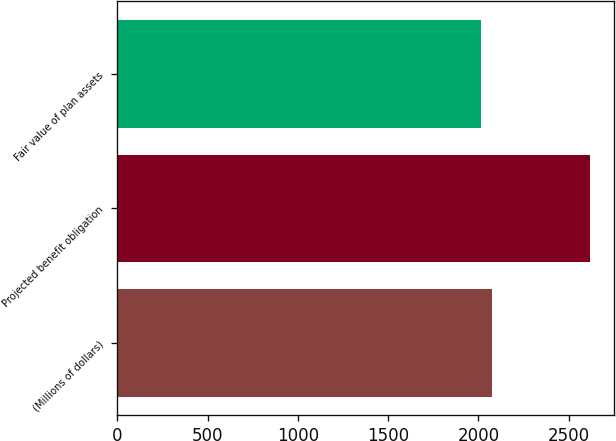Convert chart to OTSL. <chart><loc_0><loc_0><loc_500><loc_500><bar_chart><fcel>(Millions of dollars)<fcel>Projected benefit obligation<fcel>Fair value of plan assets<nl><fcel>2072.6<fcel>2618<fcel>2012<nl></chart> 